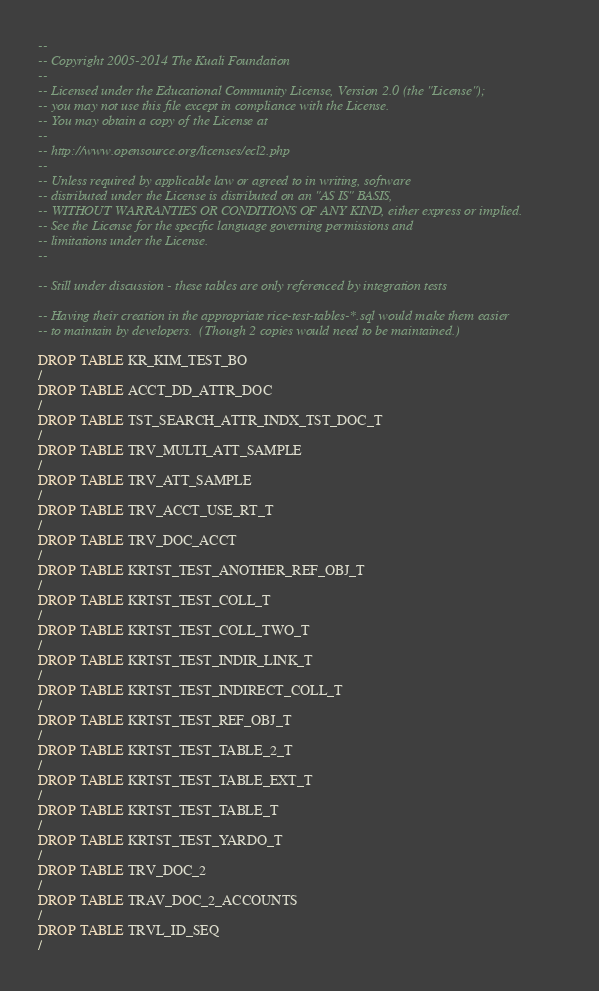<code> <loc_0><loc_0><loc_500><loc_500><_SQL_>--
-- Copyright 2005-2014 The Kuali Foundation
--
-- Licensed under the Educational Community License, Version 2.0 (the "License");
-- you may not use this file except in compliance with the License.
-- You may obtain a copy of the License at
--
-- http://www.opensource.org/licenses/ecl2.php
--
-- Unless required by applicable law or agreed to in writing, software
-- distributed under the License is distributed on an "AS IS" BASIS,
-- WITHOUT WARRANTIES OR CONDITIONS OF ANY KIND, either express or implied.
-- See the License for the specific language governing permissions and
-- limitations under the License.
--

-- Still under discussion - these tables are only referenced by integration tests

-- Having their creation in the appropriate rice-test-tables-*.sql would make them easier
-- to maintain by developers.  (Though 2 copies would need to be maintained.)

DROP TABLE KR_KIM_TEST_BO
/
DROP TABLE ACCT_DD_ATTR_DOC
/
DROP TABLE TST_SEARCH_ATTR_INDX_TST_DOC_T
/
DROP TABLE TRV_MULTI_ATT_SAMPLE
/
DROP TABLE TRV_ATT_SAMPLE
/
DROP TABLE TRV_ACCT_USE_RT_T
/
DROP TABLE TRV_DOC_ACCT
/
DROP TABLE KRTST_TEST_ANOTHER_REF_OBJ_T
/
DROP TABLE KRTST_TEST_COLL_T
/
DROP TABLE KRTST_TEST_COLL_TWO_T
/
DROP TABLE KRTST_TEST_INDIR_LINK_T
/
DROP TABLE KRTST_TEST_INDIRECT_COLL_T
/
DROP TABLE KRTST_TEST_REF_OBJ_T
/
DROP TABLE KRTST_TEST_TABLE_2_T
/
DROP TABLE KRTST_TEST_TABLE_EXT_T
/
DROP TABLE KRTST_TEST_TABLE_T
/
DROP TABLE KRTST_TEST_YARDO_T
/
DROP TABLE TRV_DOC_2
/
DROP TABLE TRAV_DOC_2_ACCOUNTS
/
DROP TABLE TRVL_ID_SEQ
/
</code> 